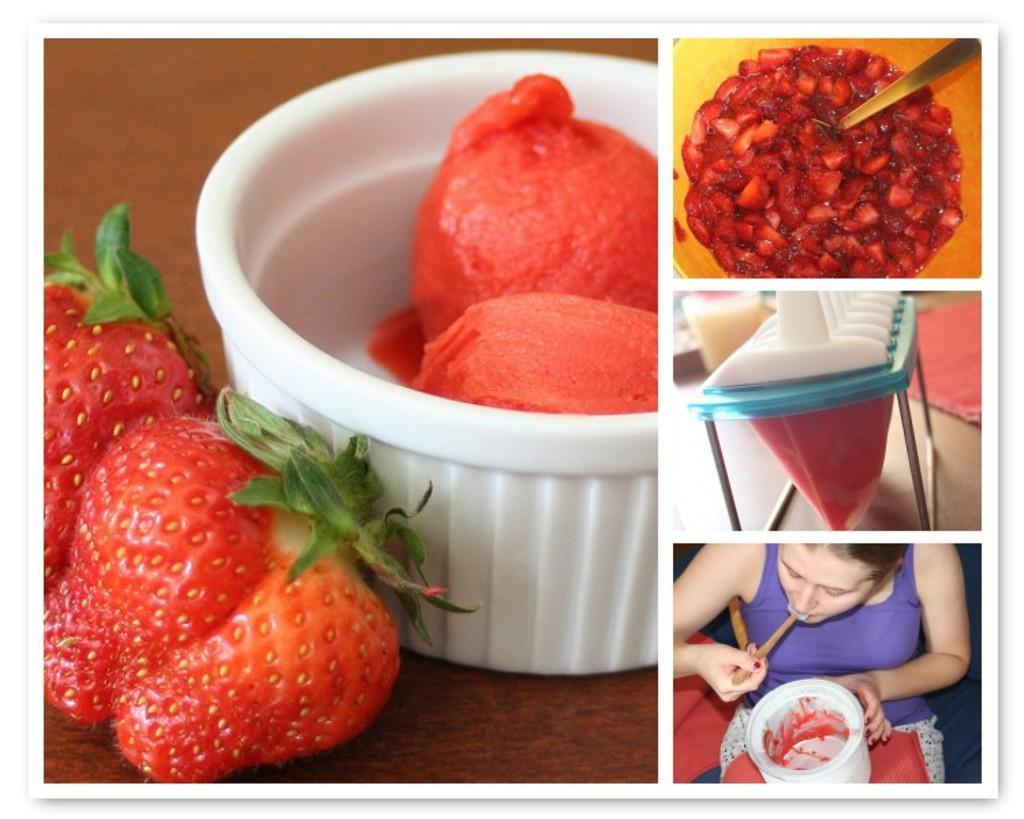In one or two sentences, can you explain what this image depicts? It is a collage picture. Bottom left side of the image there is a cup and there are some strawberries. Bottom right side of the image a woman is sitting and eating. In the middle of the image there is a table, on the table there is a stand. Top right side of the image there is a bowl, in the bowl there is food and spoon. 